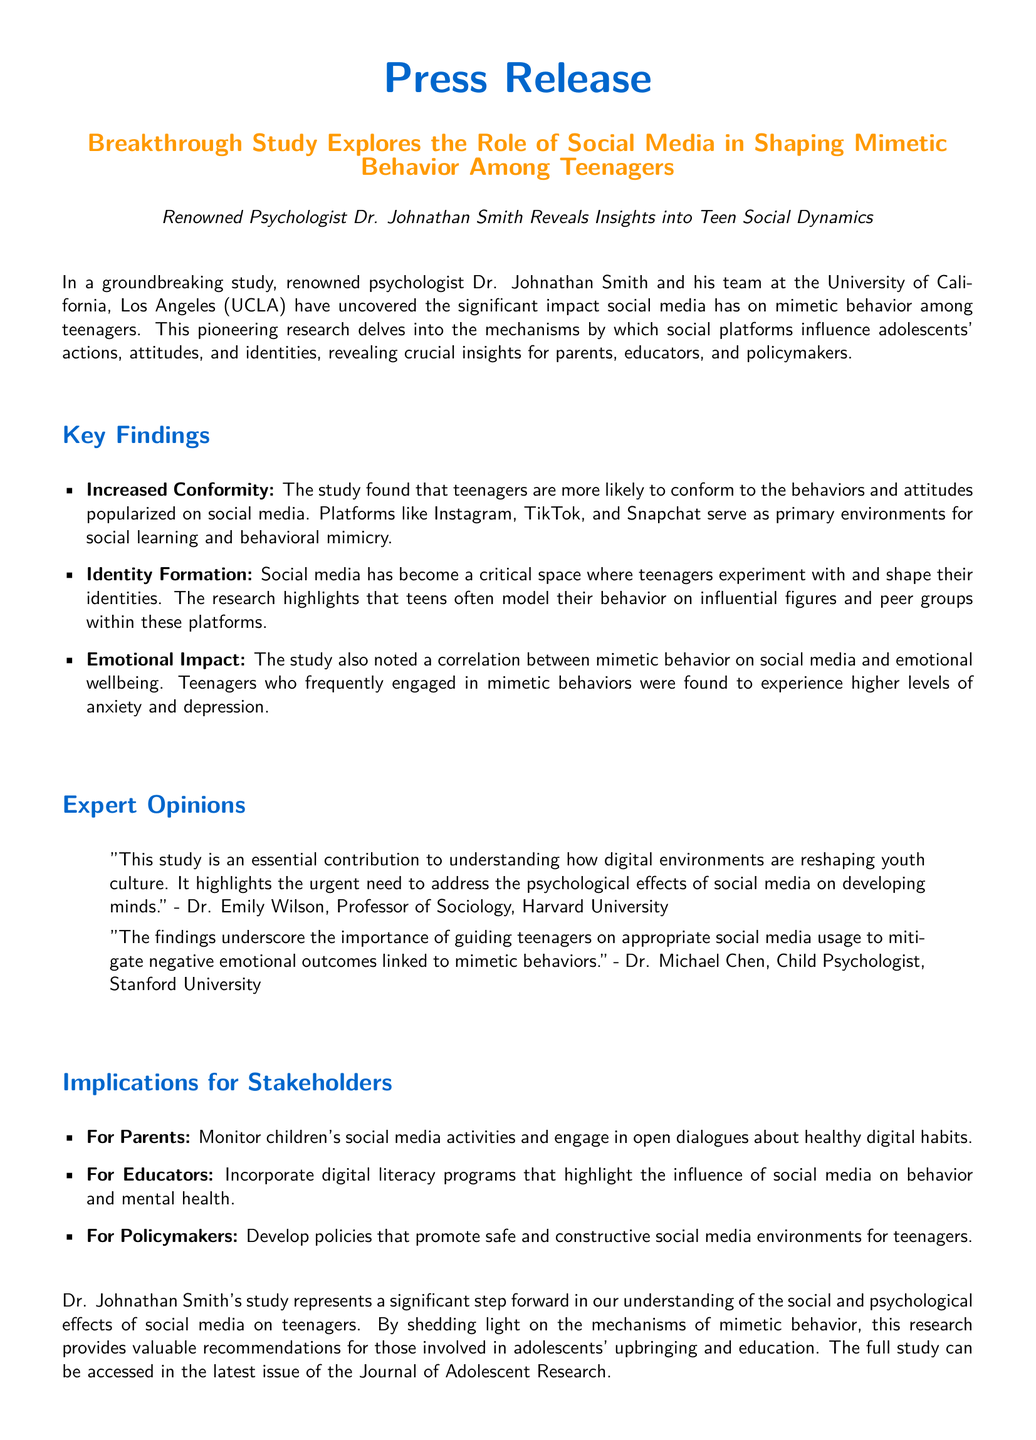What is the name of the lead researcher? The lead researcher of the study is Dr. Johnathan Smith.
Answer: Dr. Johnathan Smith What institution conducted the study? The study was conducted by a team at the University of California, Los Angeles (UCLA).
Answer: University of California, Los Angeles (UCLA) Which social media platforms are mentioned as influencers? The press release mentions Instagram, TikTok, and Snapchat as key platforms influencing behavior.
Answer: Instagram, TikTok, and Snapchat What correlation was noted in the study regarding emotional wellbeing? The study noted a correlation between mimetic behavior on social media and higher levels of anxiety and depression.
Answer: Higher levels of anxiety and depression What is one implication for parents mentioned in the document? Parents are advised to monitor children's social media activities and engage in open dialogues about healthy digital habits.
Answer: Monitor children's social media activities What type of program should educators incorporate according to the study? Educators should incorporate digital literacy programs that highlight the influence of social media on behavior and mental health.
Answer: Digital literacy programs What urgent need does Dr. Emily Wilson highlight? Dr. Emily Wilson highlights the urgent need to address the psychological effects of social media on developing minds.
Answer: Address the psychological effects of social media When was the full study accessible? The full study can be accessed in the latest issue of the Journal of Adolescent Research.
Answer: Latest issue of the Journal of Adolescent Research 